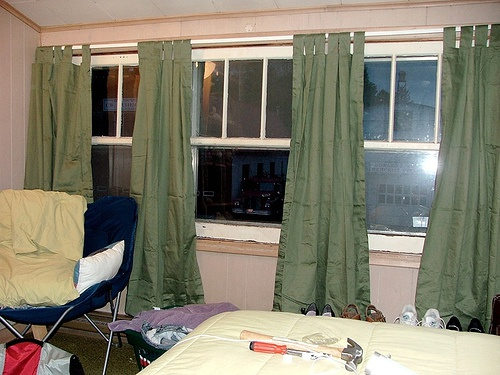Describe the objects in this image and their specific colors. I can see bed in maroon, beige, darkgray, and gray tones, chair in maroon, black, and tan tones, and car in maroon, black, and gray tones in this image. 